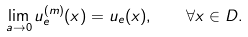Convert formula to latex. <formula><loc_0><loc_0><loc_500><loc_500>\lim _ { a \to 0 } u _ { e } ^ { ( m ) } ( x ) = u _ { e } ( x ) , \quad \forall x \in D .</formula> 